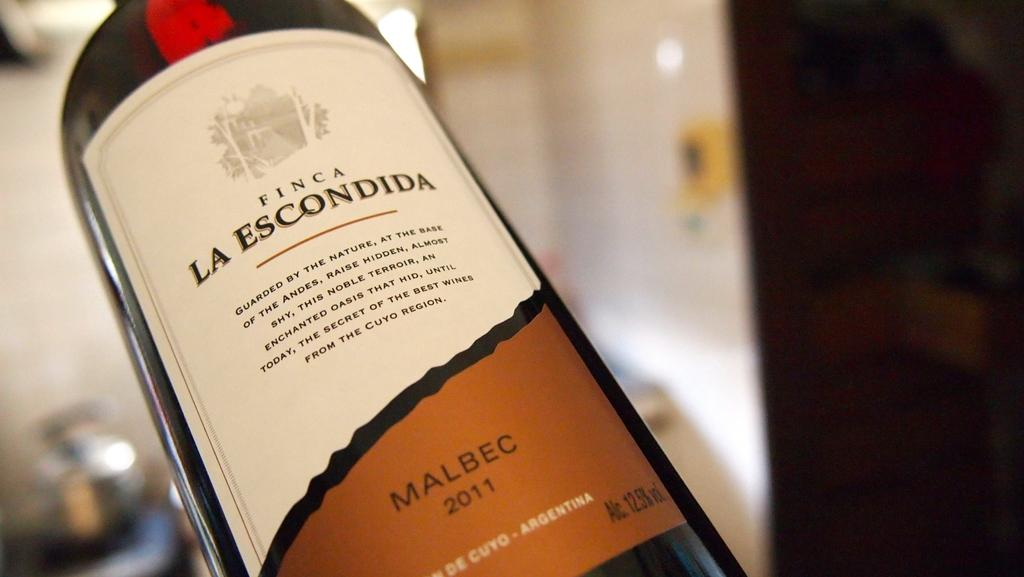<image>
Summarize the visual content of the image. A bottle of Finca La Escondida from 2011 with a white and gold label. 